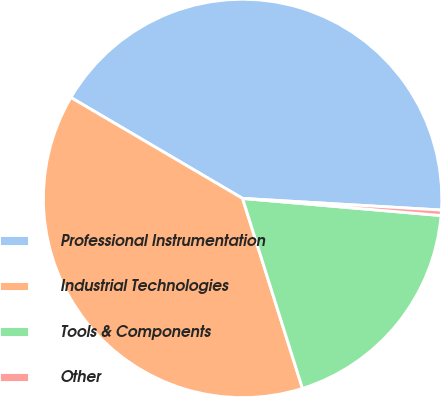Convert chart to OTSL. <chart><loc_0><loc_0><loc_500><loc_500><pie_chart><fcel>Professional Instrumentation<fcel>Industrial Technologies<fcel>Tools & Components<fcel>Other<nl><fcel>42.47%<fcel>38.32%<fcel>18.77%<fcel>0.44%<nl></chart> 